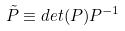<formula> <loc_0><loc_0><loc_500><loc_500>\tilde { P } \equiv d e t ( P ) P ^ { - 1 }</formula> 